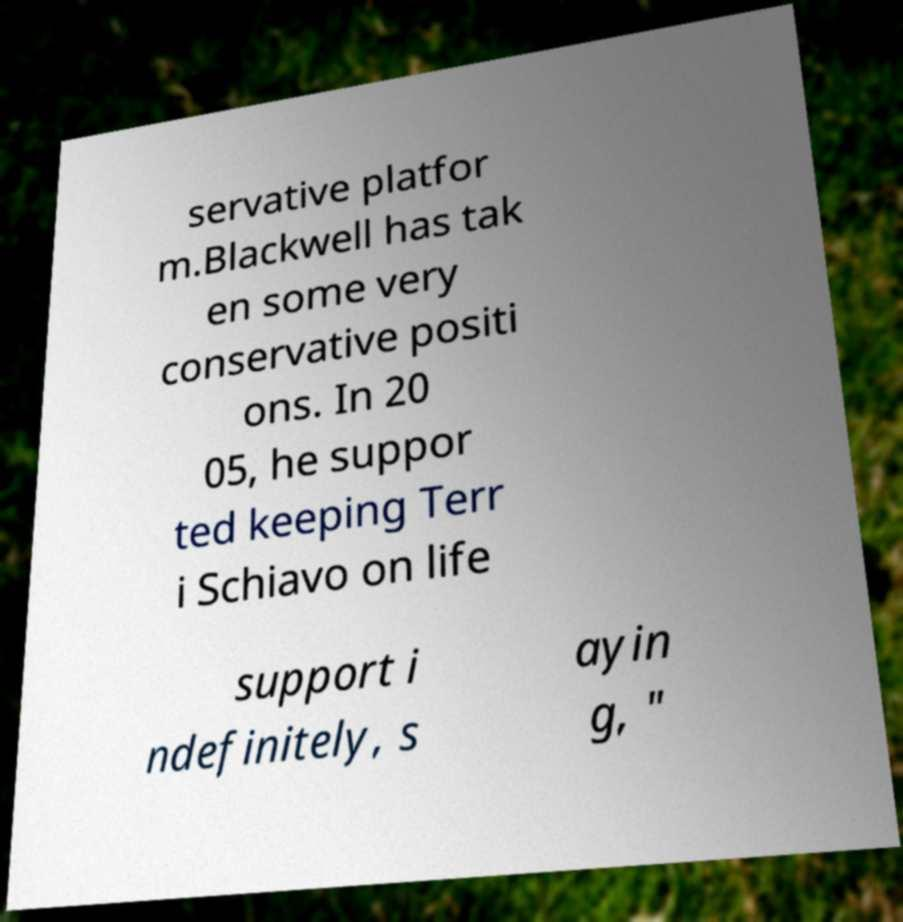Can you accurately transcribe the text from the provided image for me? servative platfor m.Blackwell has tak en some very conservative positi ons. In 20 05, he suppor ted keeping Terr i Schiavo on life support i ndefinitely, s ayin g, " 